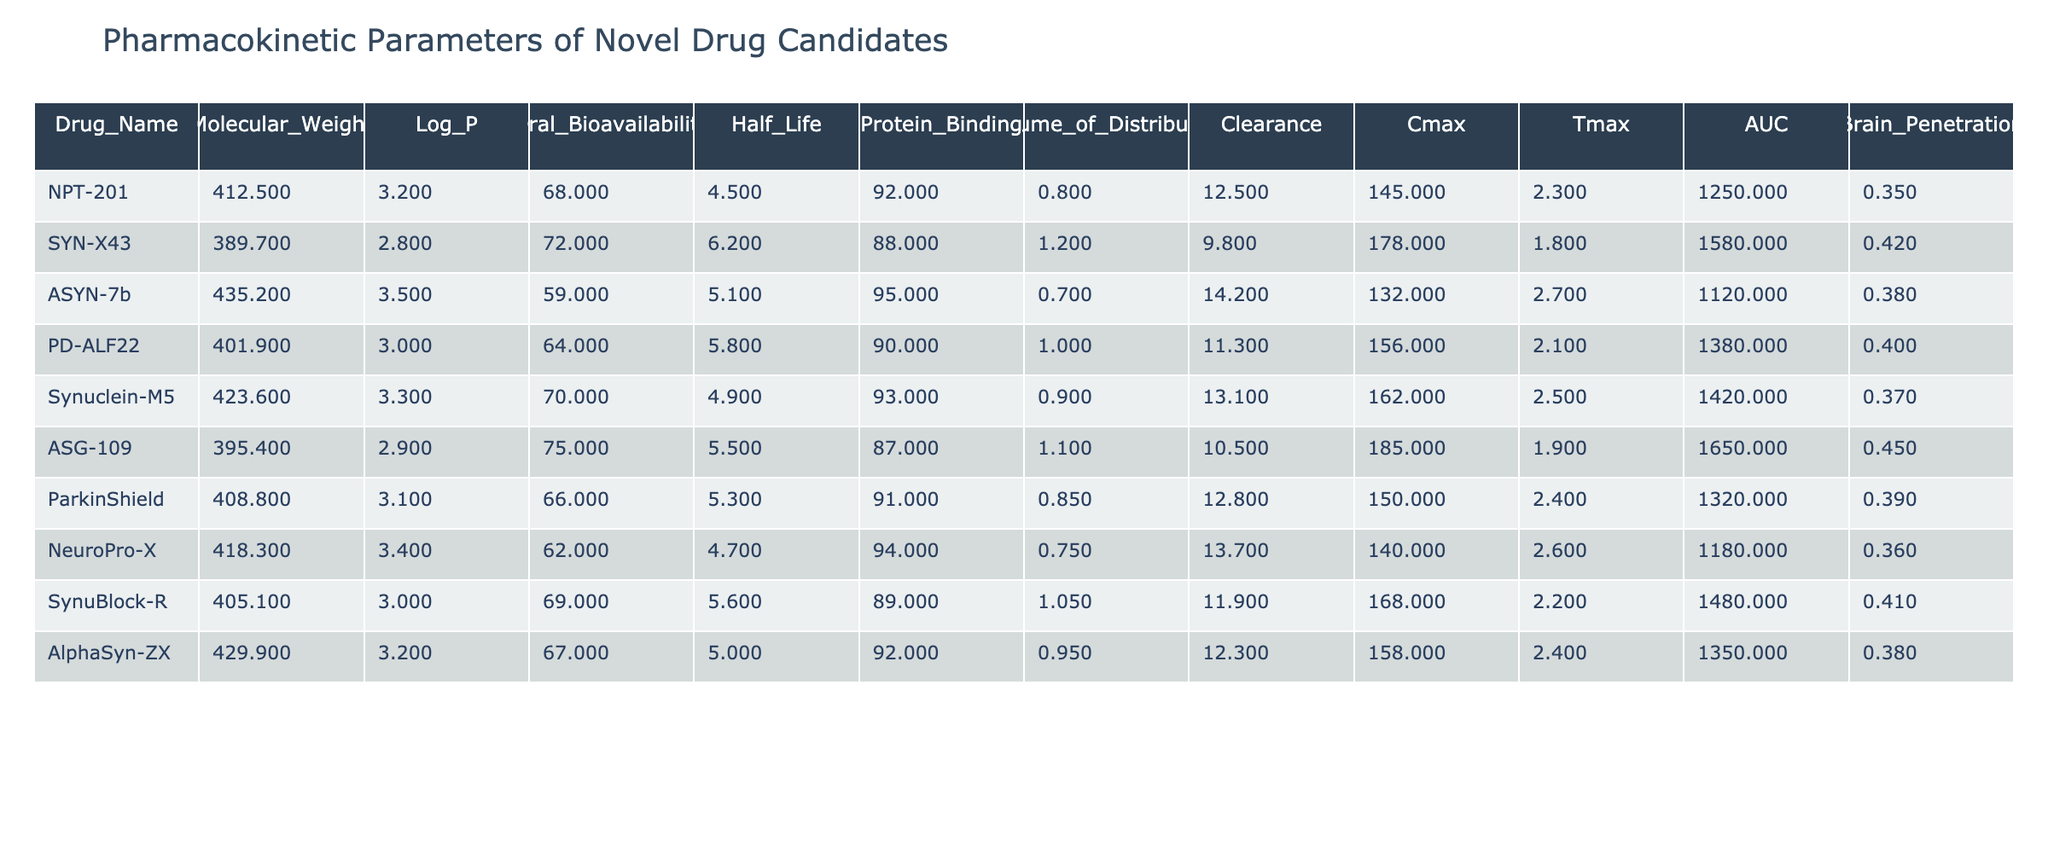What is the oral bioavailability of SYN-X43? The oral bioavailability of SYN-X43 is explicitly listed in the table under the column "Oral_Bioavailability." The value is 72.
Answer: 72 Which drug has the highest half-life? To find the drug with the highest half-life, we compare the values in the "Half_Life" column. The maximum value is 6.2, which corresponds to SYN-X43.
Answer: SYN-X43 Is the volume of distribution for ASYN-7b greater than 1.0? The volume of distribution for ASYN-7b is given as 0.7 in the table, which is less than 1.0, so the answer is no.
Answer: No What is the difference in brain penetration between ParkinShield and AlphaSyn-ZX? The brain penetration values for ParkinShield and AlphaSyn-ZX are 0.39 and 0.38, respectively. The difference is calculated as 0.39 - 0.38 = 0.01.
Answer: 0.01 What drug has the lowest protein binding, and what is its value? To find the drug with the lowest protein binding, we look at the "Protein_Binding" column. The lowest value is 87 for ASG-109.
Answer: ASG-109, 87 What is the average molecular weight of the drugs listed? First, we sum the molecular weights from the "Molecular_Weight" column: 412.5 + 389.7 + 435.2 + 401.9 + 423.6 + 395.4 + 408.8 + 418.3 + 405.1 + 429.9 = 4,229.5. There are 10 drugs, so the average is 4,229.5 / 10 = 422.95.
Answer: 422.95 Which drug has the highest Cmax value and what is that value? The Cmax values can be compared: NPT-201 has 145, SYN-X43 has 178, ASYN-7b has 132, and so forth. The maximum Cmax value is 185, which belongs to ASG-109.
Answer: ASG-109, 185 Is it true that all drugs have an oral bioavailability greater than 50%? By checking the "Oral_Bioavailability" column, all drugs listed have values above 50%, confirming that the statement is true.
Answer: Yes What is the total clearance for drugs with half-lives greater than 5? First, we identify drugs with half-lives greater than 5: SYN-X43 (6.2), ASYN-7b (5.1), PD-ALF22 (5.8), ASG-109 (5.5), and ParkinShield (5.3). Their clearances are 9.8, 14.2, 11.3, 10.5, and 12.8, respectively. The total clearance is 9.8 + 14.2 + 11.3 + 10.5 + 12.8 = 58.6.
Answer: 58.6 Which drug has the lowest AUC value and what is that value? From the "AUC" column, the values are compared and 1120 is the lowest, corresponding to ASYN-7b.
Answer: ASYN-7b, 1120 